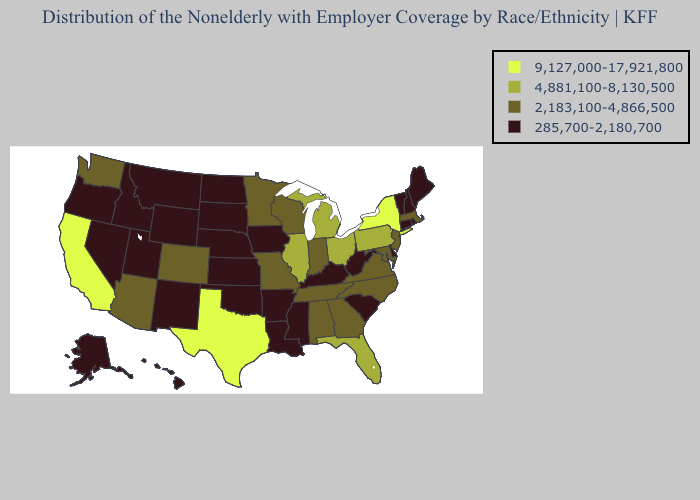What is the value of Hawaii?
Short answer required. 285,700-2,180,700. Does Rhode Island have the lowest value in the USA?
Quick response, please. Yes. Does New York have the highest value in the USA?
Write a very short answer. Yes. Name the states that have a value in the range 9,127,000-17,921,800?
Concise answer only. California, New York, Texas. Name the states that have a value in the range 285,700-2,180,700?
Write a very short answer. Alaska, Arkansas, Connecticut, Delaware, Hawaii, Idaho, Iowa, Kansas, Kentucky, Louisiana, Maine, Mississippi, Montana, Nebraska, Nevada, New Hampshire, New Mexico, North Dakota, Oklahoma, Oregon, Rhode Island, South Carolina, South Dakota, Utah, Vermont, West Virginia, Wyoming. Name the states that have a value in the range 9,127,000-17,921,800?
Concise answer only. California, New York, Texas. What is the value of Pennsylvania?
Write a very short answer. 4,881,100-8,130,500. What is the lowest value in the USA?
Give a very brief answer. 285,700-2,180,700. Name the states that have a value in the range 4,881,100-8,130,500?
Be succinct. Florida, Illinois, Michigan, Ohio, Pennsylvania. Which states have the lowest value in the Northeast?
Short answer required. Connecticut, Maine, New Hampshire, Rhode Island, Vermont. Among the states that border Vermont , does New York have the highest value?
Write a very short answer. Yes. Name the states that have a value in the range 9,127,000-17,921,800?
Concise answer only. California, New York, Texas. Name the states that have a value in the range 4,881,100-8,130,500?
Concise answer only. Florida, Illinois, Michigan, Ohio, Pennsylvania. What is the value of California?
Short answer required. 9,127,000-17,921,800. What is the value of Iowa?
Be succinct. 285,700-2,180,700. 